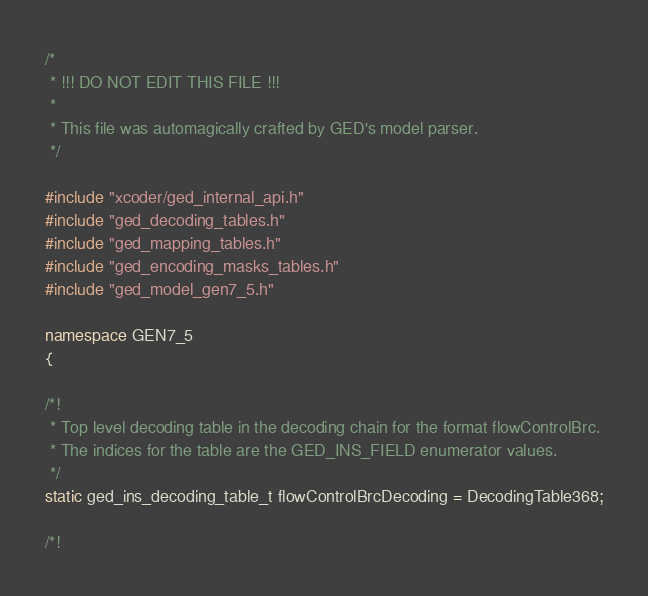Convert code to text. <code><loc_0><loc_0><loc_500><loc_500><_C++_>/*
 * !!! DO NOT EDIT THIS FILE !!!
 *
 * This file was automagically crafted by GED's model parser.
 */

#include "xcoder/ged_internal_api.h"
#include "ged_decoding_tables.h"
#include "ged_mapping_tables.h"
#include "ged_encoding_masks_tables.h"
#include "ged_model_gen7_5.h"

namespace GEN7_5
{

/*!
 * Top level decoding table in the decoding chain for the format flowControlBrc.
 * The indices for the table are the GED_INS_FIELD enumerator values.
 */
static ged_ins_decoding_table_t flowControlBrcDecoding = DecodingTable368;

/*!</code> 